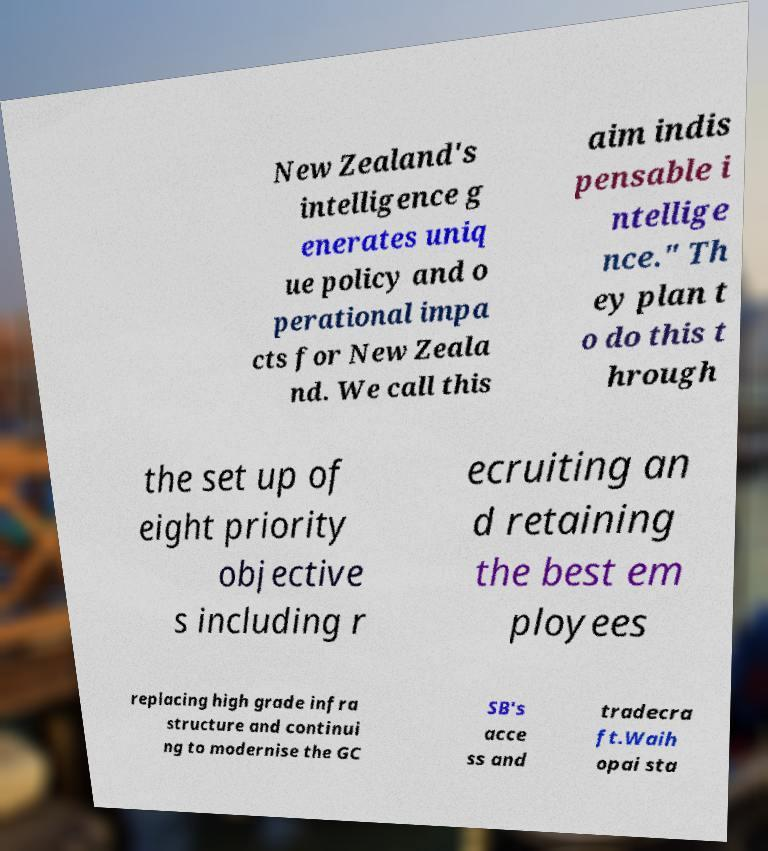For documentation purposes, I need the text within this image transcribed. Could you provide that? New Zealand's intelligence g enerates uniq ue policy and o perational impa cts for New Zeala nd. We call this aim indis pensable i ntellige nce." Th ey plan t o do this t hrough the set up of eight priority objective s including r ecruiting an d retaining the best em ployees replacing high grade infra structure and continui ng to modernise the GC SB's acce ss and tradecra ft.Waih opai sta 